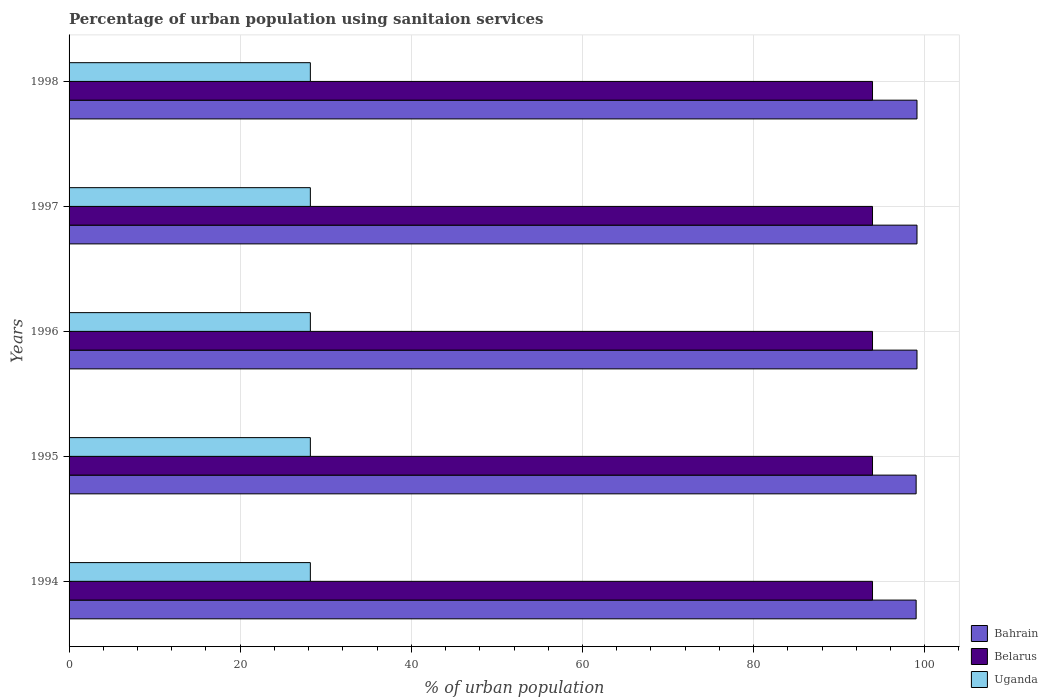How many groups of bars are there?
Provide a succinct answer. 5. Are the number of bars per tick equal to the number of legend labels?
Ensure brevity in your answer.  Yes. How many bars are there on the 4th tick from the bottom?
Your answer should be compact. 3. What is the percentage of urban population using sanitaion services in Uganda in 1995?
Make the answer very short. 28.2. Across all years, what is the maximum percentage of urban population using sanitaion services in Uganda?
Provide a short and direct response. 28.2. What is the total percentage of urban population using sanitaion services in Bahrain in the graph?
Provide a succinct answer. 495.3. What is the difference between the percentage of urban population using sanitaion services in Uganda in 1995 and the percentage of urban population using sanitaion services in Bahrain in 1998?
Ensure brevity in your answer.  -70.9. What is the average percentage of urban population using sanitaion services in Belarus per year?
Your response must be concise. 93.9. In the year 1994, what is the difference between the percentage of urban population using sanitaion services in Belarus and percentage of urban population using sanitaion services in Bahrain?
Keep it short and to the point. -5.1. Is the percentage of urban population using sanitaion services in Uganda in 1995 less than that in 1997?
Offer a terse response. No. In how many years, is the percentage of urban population using sanitaion services in Belarus greater than the average percentage of urban population using sanitaion services in Belarus taken over all years?
Make the answer very short. 0. Is the sum of the percentage of urban population using sanitaion services in Belarus in 1995 and 1998 greater than the maximum percentage of urban population using sanitaion services in Uganda across all years?
Give a very brief answer. Yes. What does the 3rd bar from the top in 1998 represents?
Make the answer very short. Bahrain. What does the 1st bar from the bottom in 1997 represents?
Your response must be concise. Bahrain. Is it the case that in every year, the sum of the percentage of urban population using sanitaion services in Belarus and percentage of urban population using sanitaion services in Uganda is greater than the percentage of urban population using sanitaion services in Bahrain?
Ensure brevity in your answer.  Yes. How many bars are there?
Give a very brief answer. 15. Are all the bars in the graph horizontal?
Provide a succinct answer. Yes. How many years are there in the graph?
Your answer should be compact. 5. Are the values on the major ticks of X-axis written in scientific E-notation?
Keep it short and to the point. No. Does the graph contain grids?
Your answer should be compact. Yes. How are the legend labels stacked?
Offer a very short reply. Vertical. What is the title of the graph?
Offer a terse response. Percentage of urban population using sanitaion services. Does "Zimbabwe" appear as one of the legend labels in the graph?
Ensure brevity in your answer.  No. What is the label or title of the X-axis?
Provide a short and direct response. % of urban population. What is the label or title of the Y-axis?
Make the answer very short. Years. What is the % of urban population of Belarus in 1994?
Offer a very short reply. 93.9. What is the % of urban population of Uganda in 1994?
Offer a terse response. 28.2. What is the % of urban population in Belarus in 1995?
Your response must be concise. 93.9. What is the % of urban population in Uganda in 1995?
Your response must be concise. 28.2. What is the % of urban population in Bahrain in 1996?
Provide a short and direct response. 99.1. What is the % of urban population of Belarus in 1996?
Your answer should be compact. 93.9. What is the % of urban population in Uganda in 1996?
Your answer should be very brief. 28.2. What is the % of urban population of Bahrain in 1997?
Give a very brief answer. 99.1. What is the % of urban population in Belarus in 1997?
Offer a terse response. 93.9. What is the % of urban population of Uganda in 1997?
Offer a terse response. 28.2. What is the % of urban population in Bahrain in 1998?
Offer a very short reply. 99.1. What is the % of urban population of Belarus in 1998?
Provide a short and direct response. 93.9. What is the % of urban population of Uganda in 1998?
Your answer should be very brief. 28.2. Across all years, what is the maximum % of urban population in Bahrain?
Keep it short and to the point. 99.1. Across all years, what is the maximum % of urban population of Belarus?
Keep it short and to the point. 93.9. Across all years, what is the maximum % of urban population of Uganda?
Make the answer very short. 28.2. Across all years, what is the minimum % of urban population in Bahrain?
Offer a very short reply. 99. Across all years, what is the minimum % of urban population in Belarus?
Make the answer very short. 93.9. Across all years, what is the minimum % of urban population in Uganda?
Make the answer very short. 28.2. What is the total % of urban population in Bahrain in the graph?
Your answer should be very brief. 495.3. What is the total % of urban population of Belarus in the graph?
Keep it short and to the point. 469.5. What is the total % of urban population of Uganda in the graph?
Your answer should be very brief. 141. What is the difference between the % of urban population of Bahrain in 1994 and that in 1995?
Offer a very short reply. 0. What is the difference between the % of urban population in Bahrain in 1994 and that in 1996?
Provide a succinct answer. -0.1. What is the difference between the % of urban population of Belarus in 1994 and that in 1997?
Make the answer very short. 0. What is the difference between the % of urban population of Bahrain in 1994 and that in 1998?
Your answer should be compact. -0.1. What is the difference between the % of urban population in Belarus in 1994 and that in 1998?
Provide a short and direct response. 0. What is the difference between the % of urban population in Uganda in 1994 and that in 1998?
Keep it short and to the point. 0. What is the difference between the % of urban population of Belarus in 1995 and that in 1996?
Provide a succinct answer. 0. What is the difference between the % of urban population of Uganda in 1995 and that in 1996?
Provide a short and direct response. 0. What is the difference between the % of urban population in Bahrain in 1995 and that in 1997?
Your answer should be compact. -0.1. What is the difference between the % of urban population in Belarus in 1995 and that in 1998?
Ensure brevity in your answer.  0. What is the difference between the % of urban population in Uganda in 1995 and that in 1998?
Give a very brief answer. 0. What is the difference between the % of urban population of Belarus in 1996 and that in 1997?
Offer a very short reply. 0. What is the difference between the % of urban population in Bahrain in 1996 and that in 1998?
Offer a very short reply. 0. What is the difference between the % of urban population in Belarus in 1996 and that in 1998?
Offer a terse response. 0. What is the difference between the % of urban population of Uganda in 1996 and that in 1998?
Your answer should be compact. 0. What is the difference between the % of urban population of Bahrain in 1997 and that in 1998?
Provide a succinct answer. 0. What is the difference between the % of urban population in Bahrain in 1994 and the % of urban population in Belarus in 1995?
Your answer should be compact. 5.1. What is the difference between the % of urban population in Bahrain in 1994 and the % of urban population in Uganda in 1995?
Provide a short and direct response. 70.8. What is the difference between the % of urban population in Belarus in 1994 and the % of urban population in Uganda in 1995?
Your answer should be very brief. 65.7. What is the difference between the % of urban population in Bahrain in 1994 and the % of urban population in Belarus in 1996?
Ensure brevity in your answer.  5.1. What is the difference between the % of urban population in Bahrain in 1994 and the % of urban population in Uganda in 1996?
Keep it short and to the point. 70.8. What is the difference between the % of urban population of Belarus in 1994 and the % of urban population of Uganda in 1996?
Your response must be concise. 65.7. What is the difference between the % of urban population in Bahrain in 1994 and the % of urban population in Uganda in 1997?
Your answer should be compact. 70.8. What is the difference between the % of urban population in Belarus in 1994 and the % of urban population in Uganda in 1997?
Provide a short and direct response. 65.7. What is the difference between the % of urban population in Bahrain in 1994 and the % of urban population in Uganda in 1998?
Your answer should be compact. 70.8. What is the difference between the % of urban population in Belarus in 1994 and the % of urban population in Uganda in 1998?
Your answer should be very brief. 65.7. What is the difference between the % of urban population of Bahrain in 1995 and the % of urban population of Uganda in 1996?
Your response must be concise. 70.8. What is the difference between the % of urban population in Belarus in 1995 and the % of urban population in Uganda in 1996?
Your response must be concise. 65.7. What is the difference between the % of urban population in Bahrain in 1995 and the % of urban population in Uganda in 1997?
Provide a succinct answer. 70.8. What is the difference between the % of urban population of Belarus in 1995 and the % of urban population of Uganda in 1997?
Offer a terse response. 65.7. What is the difference between the % of urban population of Bahrain in 1995 and the % of urban population of Belarus in 1998?
Provide a succinct answer. 5.1. What is the difference between the % of urban population of Bahrain in 1995 and the % of urban population of Uganda in 1998?
Keep it short and to the point. 70.8. What is the difference between the % of urban population in Belarus in 1995 and the % of urban population in Uganda in 1998?
Offer a very short reply. 65.7. What is the difference between the % of urban population in Bahrain in 1996 and the % of urban population in Belarus in 1997?
Keep it short and to the point. 5.2. What is the difference between the % of urban population in Bahrain in 1996 and the % of urban population in Uganda in 1997?
Make the answer very short. 70.9. What is the difference between the % of urban population of Belarus in 1996 and the % of urban population of Uganda in 1997?
Provide a succinct answer. 65.7. What is the difference between the % of urban population in Bahrain in 1996 and the % of urban population in Belarus in 1998?
Keep it short and to the point. 5.2. What is the difference between the % of urban population in Bahrain in 1996 and the % of urban population in Uganda in 1998?
Your answer should be very brief. 70.9. What is the difference between the % of urban population in Belarus in 1996 and the % of urban population in Uganda in 1998?
Offer a very short reply. 65.7. What is the difference between the % of urban population in Bahrain in 1997 and the % of urban population in Uganda in 1998?
Offer a terse response. 70.9. What is the difference between the % of urban population in Belarus in 1997 and the % of urban population in Uganda in 1998?
Make the answer very short. 65.7. What is the average % of urban population in Bahrain per year?
Provide a short and direct response. 99.06. What is the average % of urban population in Belarus per year?
Ensure brevity in your answer.  93.9. What is the average % of urban population in Uganda per year?
Your answer should be compact. 28.2. In the year 1994, what is the difference between the % of urban population of Bahrain and % of urban population of Uganda?
Provide a short and direct response. 70.8. In the year 1994, what is the difference between the % of urban population in Belarus and % of urban population in Uganda?
Provide a short and direct response. 65.7. In the year 1995, what is the difference between the % of urban population in Bahrain and % of urban population in Belarus?
Your response must be concise. 5.1. In the year 1995, what is the difference between the % of urban population in Bahrain and % of urban population in Uganda?
Offer a terse response. 70.8. In the year 1995, what is the difference between the % of urban population in Belarus and % of urban population in Uganda?
Keep it short and to the point. 65.7. In the year 1996, what is the difference between the % of urban population in Bahrain and % of urban population in Belarus?
Give a very brief answer. 5.2. In the year 1996, what is the difference between the % of urban population of Bahrain and % of urban population of Uganda?
Your answer should be compact. 70.9. In the year 1996, what is the difference between the % of urban population of Belarus and % of urban population of Uganda?
Your answer should be compact. 65.7. In the year 1997, what is the difference between the % of urban population in Bahrain and % of urban population in Belarus?
Keep it short and to the point. 5.2. In the year 1997, what is the difference between the % of urban population of Bahrain and % of urban population of Uganda?
Your answer should be compact. 70.9. In the year 1997, what is the difference between the % of urban population of Belarus and % of urban population of Uganda?
Give a very brief answer. 65.7. In the year 1998, what is the difference between the % of urban population in Bahrain and % of urban population in Belarus?
Your response must be concise. 5.2. In the year 1998, what is the difference between the % of urban population in Bahrain and % of urban population in Uganda?
Provide a succinct answer. 70.9. In the year 1998, what is the difference between the % of urban population of Belarus and % of urban population of Uganda?
Ensure brevity in your answer.  65.7. What is the ratio of the % of urban population of Belarus in 1994 to that in 1995?
Provide a short and direct response. 1. What is the ratio of the % of urban population in Bahrain in 1994 to that in 1996?
Provide a short and direct response. 1. What is the ratio of the % of urban population in Bahrain in 1994 to that in 1997?
Your response must be concise. 1. What is the ratio of the % of urban population of Uganda in 1994 to that in 1997?
Your answer should be very brief. 1. What is the ratio of the % of urban population in Bahrain in 1994 to that in 1998?
Your response must be concise. 1. What is the ratio of the % of urban population of Belarus in 1994 to that in 1998?
Your answer should be very brief. 1. What is the ratio of the % of urban population of Uganda in 1994 to that in 1998?
Your response must be concise. 1. What is the ratio of the % of urban population in Bahrain in 1995 to that in 1996?
Your answer should be compact. 1. What is the ratio of the % of urban population of Bahrain in 1995 to that in 1997?
Make the answer very short. 1. What is the ratio of the % of urban population of Bahrain in 1995 to that in 1998?
Ensure brevity in your answer.  1. What is the ratio of the % of urban population of Uganda in 1995 to that in 1998?
Give a very brief answer. 1. What is the ratio of the % of urban population of Belarus in 1996 to that in 1997?
Provide a short and direct response. 1. What is the ratio of the % of urban population in Belarus in 1996 to that in 1998?
Give a very brief answer. 1. What is the ratio of the % of urban population of Uganda in 1996 to that in 1998?
Your response must be concise. 1. What is the ratio of the % of urban population of Bahrain in 1997 to that in 1998?
Offer a very short reply. 1. What is the ratio of the % of urban population in Belarus in 1997 to that in 1998?
Your response must be concise. 1. What is the ratio of the % of urban population of Uganda in 1997 to that in 1998?
Your response must be concise. 1. What is the difference between the highest and the second highest % of urban population in Bahrain?
Your answer should be compact. 0. What is the difference between the highest and the second highest % of urban population of Uganda?
Keep it short and to the point. 0. What is the difference between the highest and the lowest % of urban population of Bahrain?
Ensure brevity in your answer.  0.1. What is the difference between the highest and the lowest % of urban population in Uganda?
Make the answer very short. 0. 